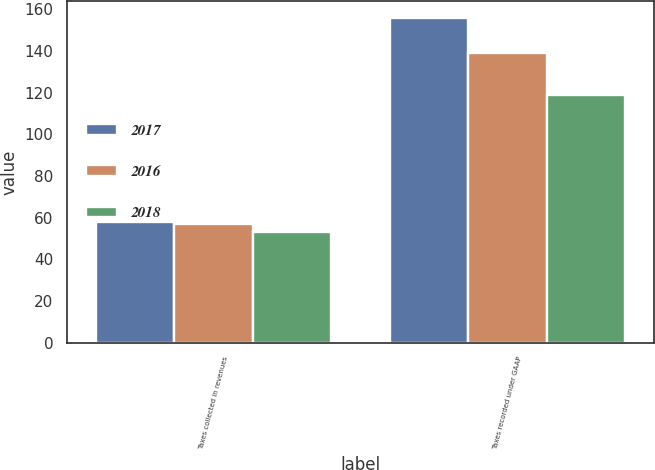<chart> <loc_0><loc_0><loc_500><loc_500><stacked_bar_chart><ecel><fcel>Taxes collected in revenues<fcel>Taxes recorded under GAAP<nl><fcel>2017<fcel>58<fcel>156<nl><fcel>2016<fcel>57<fcel>139<nl><fcel>2018<fcel>53<fcel>119<nl></chart> 